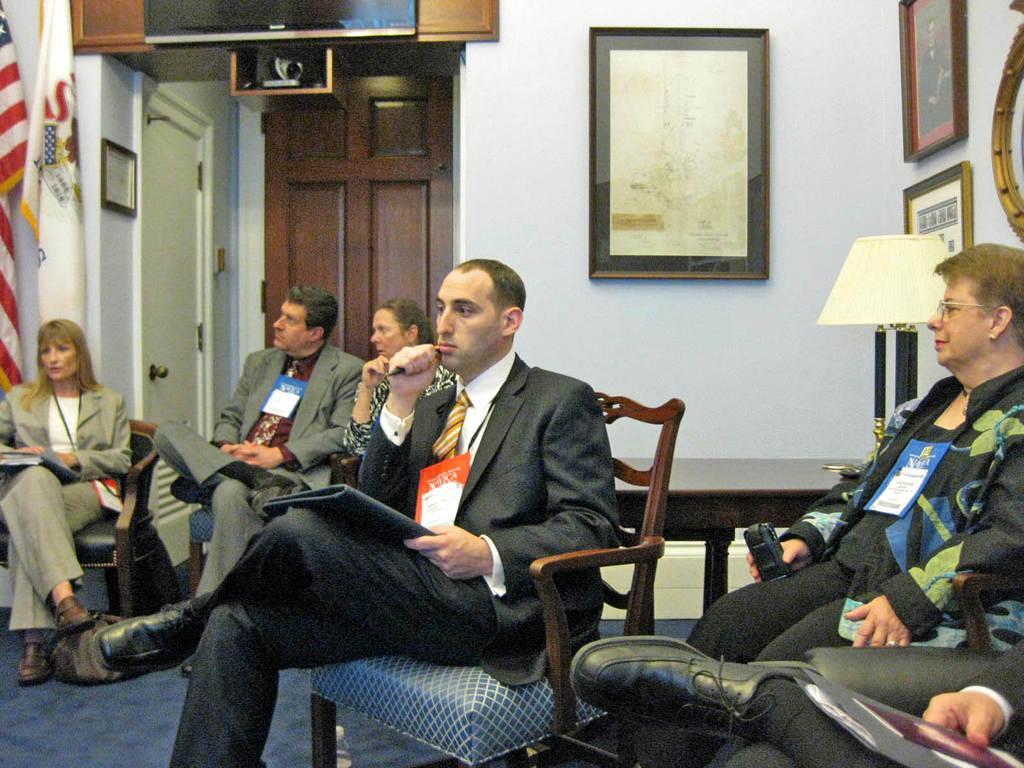How would you summarize this image in a sentence or two? In the image there are few men and women in suits sitting on chairs and behind them there is a table and lamp on the right side and flags on the left side in front of the wall and over the background there are doors on the wall with photographs on either side of it. 